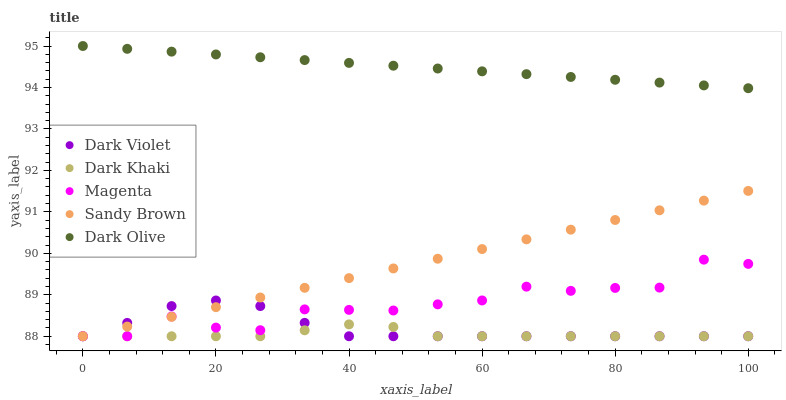Does Dark Khaki have the minimum area under the curve?
Answer yes or no. Yes. Does Dark Olive have the maximum area under the curve?
Answer yes or no. Yes. Does Magenta have the minimum area under the curve?
Answer yes or no. No. Does Magenta have the maximum area under the curve?
Answer yes or no. No. Is Dark Olive the smoothest?
Answer yes or no. Yes. Is Magenta the roughest?
Answer yes or no. Yes. Is Magenta the smoothest?
Answer yes or no. No. Is Dark Olive the roughest?
Answer yes or no. No. Does Dark Khaki have the lowest value?
Answer yes or no. Yes. Does Dark Olive have the lowest value?
Answer yes or no. No. Does Dark Olive have the highest value?
Answer yes or no. Yes. Does Magenta have the highest value?
Answer yes or no. No. Is Dark Khaki less than Dark Olive?
Answer yes or no. Yes. Is Dark Olive greater than Dark Khaki?
Answer yes or no. Yes. Does Sandy Brown intersect Magenta?
Answer yes or no. Yes. Is Sandy Brown less than Magenta?
Answer yes or no. No. Is Sandy Brown greater than Magenta?
Answer yes or no. No. Does Dark Khaki intersect Dark Olive?
Answer yes or no. No. 